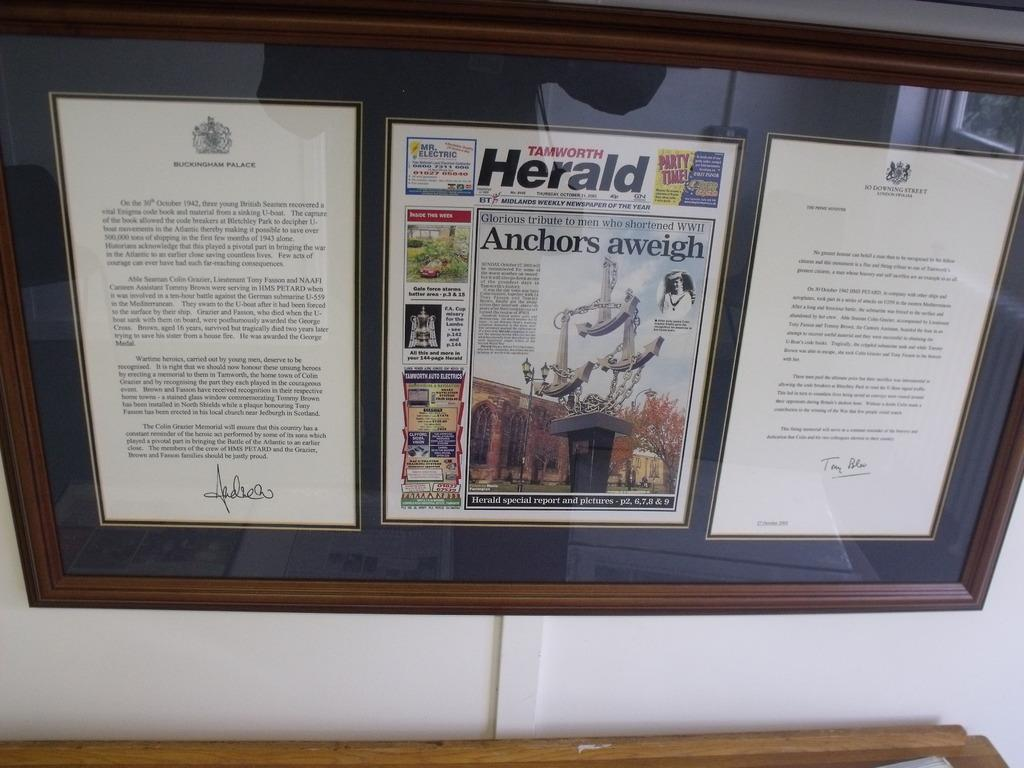<image>
Describe the image concisely. A glass display containing a copy of the Tamworth Herald 